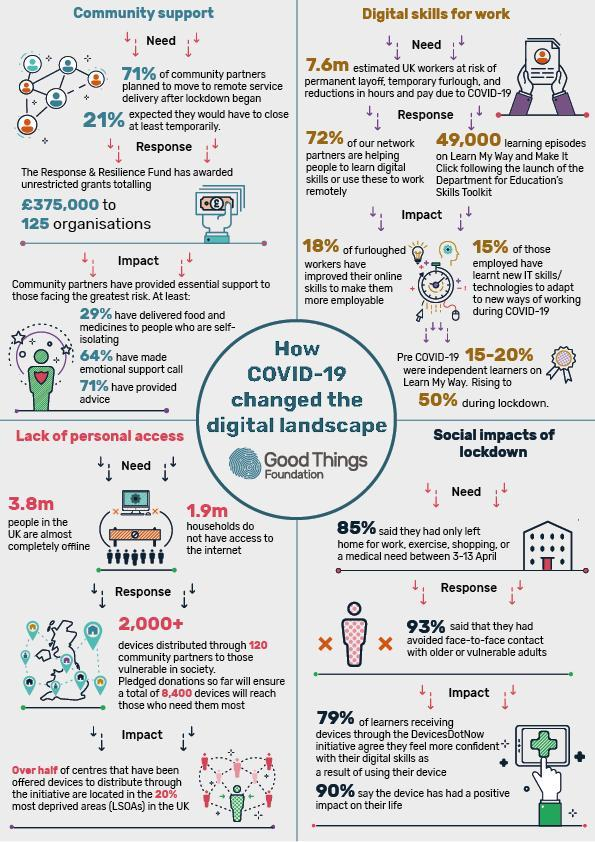What percentage of independent learners were on Learn My Way website during the lockdown?
Answer the question with a short phrase. 50% How much is the total grants (in pounds) offered by the Response & Resilience Fund in the UK due to the COVID-19 crisis? 375,000 How many organisations in the UK were awarded unrestricted grants by the Response & Resilience Fund to overcome the COVID-19 crisis? 125 How many people in the UK are completely offline during the lockdown period? 3.8m How many households in the UK do not have access to the internet during the lockdown period? 1.9m 